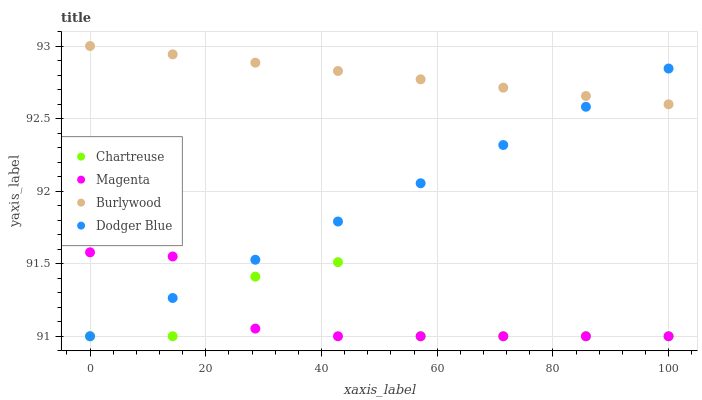Does Magenta have the minimum area under the curve?
Answer yes or no. Yes. Does Burlywood have the maximum area under the curve?
Answer yes or no. Yes. Does Chartreuse have the minimum area under the curve?
Answer yes or no. No. Does Chartreuse have the maximum area under the curve?
Answer yes or no. No. Is Dodger Blue the smoothest?
Answer yes or no. Yes. Is Chartreuse the roughest?
Answer yes or no. Yes. Is Chartreuse the smoothest?
Answer yes or no. No. Is Dodger Blue the roughest?
Answer yes or no. No. Does Chartreuse have the lowest value?
Answer yes or no. Yes. Does Burlywood have the highest value?
Answer yes or no. Yes. Does Dodger Blue have the highest value?
Answer yes or no. No. Is Chartreuse less than Burlywood?
Answer yes or no. Yes. Is Burlywood greater than Magenta?
Answer yes or no. Yes. Does Chartreuse intersect Magenta?
Answer yes or no. Yes. Is Chartreuse less than Magenta?
Answer yes or no. No. Is Chartreuse greater than Magenta?
Answer yes or no. No. Does Chartreuse intersect Burlywood?
Answer yes or no. No. 